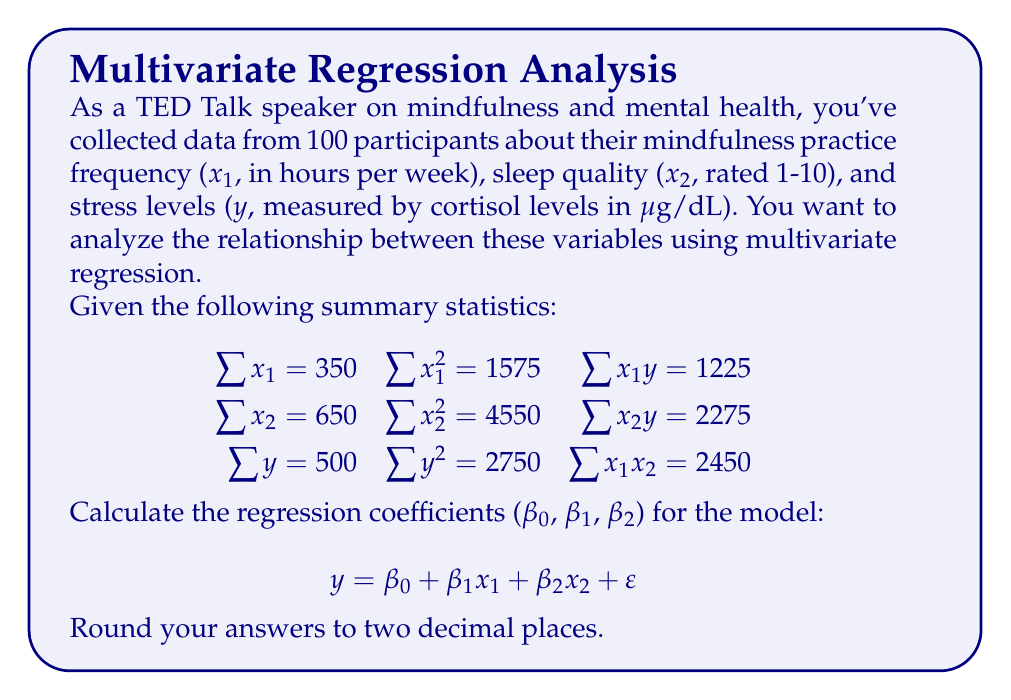Teach me how to tackle this problem. To solve this multivariate regression problem, we'll use the normal equations method. The steps are as follows:

1) First, we need to calculate the means of x₁, x₂, and y:

   $\bar{x}_1 = \frac{\sum x_1}{n} = \frac{350}{100} = 3.5$
   $\bar{x}_2 = \frac{\sum x_2}{n} = \frac{650}{100} = 6.5$
   $\bar{y} = \frac{\sum y}{n} = \frac{500}{100} = 5$

2) Next, we calculate the sums of squares and cross-products:

   $S_{xx_1} = \sum x_1^2 - n\bar{x}_1^2 = 1575 - 100(3.5)^2 = 350$
   $S_{xx_2} = \sum x_2^2 - n\bar{x}_2^2 = 4550 - 100(6.5)^2 = 325$
   $S_{yy} = \sum y^2 - n\bar{y}^2 = 2750 - 100(5)^2 = 250$
   $S_{x_1y} = \sum x_1y - n\bar{x}_1\bar{y} = 1225 - 100(3.5)(5) = 100$
   $S_{x_2y} = \sum x_2y - n\bar{x}_2\bar{y} = 2275 - 100(6.5)(5) = 50$
   $S_{x_1x_2} = \sum x_1x_2 - n\bar{x}_1\bar{x}_2 = 2450 - 100(3.5)(6.5) = 175$

3) Now we can set up the normal equations:

   $S_{xx_1}\beta_1 + S_{x_1x_2}\beta_2 = S_{x_1y}$
   $S_{x_1x_2}\beta_1 + S_{xx_2}\beta_2 = S_{x_2y}$

4) Substituting the values:

   $350\beta_1 + 175\beta_2 = 100$
   $175\beta_1 + 325\beta_2 = 50$

5) Solve this system of equations:
   Multiply the first equation by 175 and the second by 350:

   $61250\beta_1 + 30625\beta_2 = 17500$
   $61250\beta_1 + 113750\beta_2 = 17500$

   Subtracting the first from the second:

   $83125\beta_2 = 0$
   $\beta_2 = 0$

   Substituting back into the first equation:

   $350\beta_1 = 100$
   $\beta_1 = \frac{100}{350} \approx 0.29$

6) Finally, calculate β₀:

   $\beta_0 = \bar{y} - \beta_1\bar{x}_1 - \beta_2\bar{x}_2$
   $\beta_0 = 5 - 0.29(3.5) - 0(6.5) = 3.99$

Therefore, the regression coefficients are:
β₀ ≈ 3.99, β₁ ≈ 0.29, β₂ = 0
Answer: β₀ = 3.99, β₁ = 0.29, β₂ = 0 